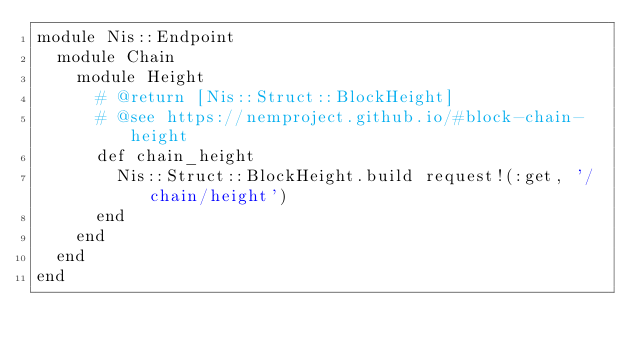Convert code to text. <code><loc_0><loc_0><loc_500><loc_500><_Ruby_>module Nis::Endpoint
  module Chain
    module Height
      # @return [Nis::Struct::BlockHeight]
      # @see https://nemproject.github.io/#block-chain-height
      def chain_height
        Nis::Struct::BlockHeight.build request!(:get, '/chain/height')
      end
    end
  end
end
</code> 